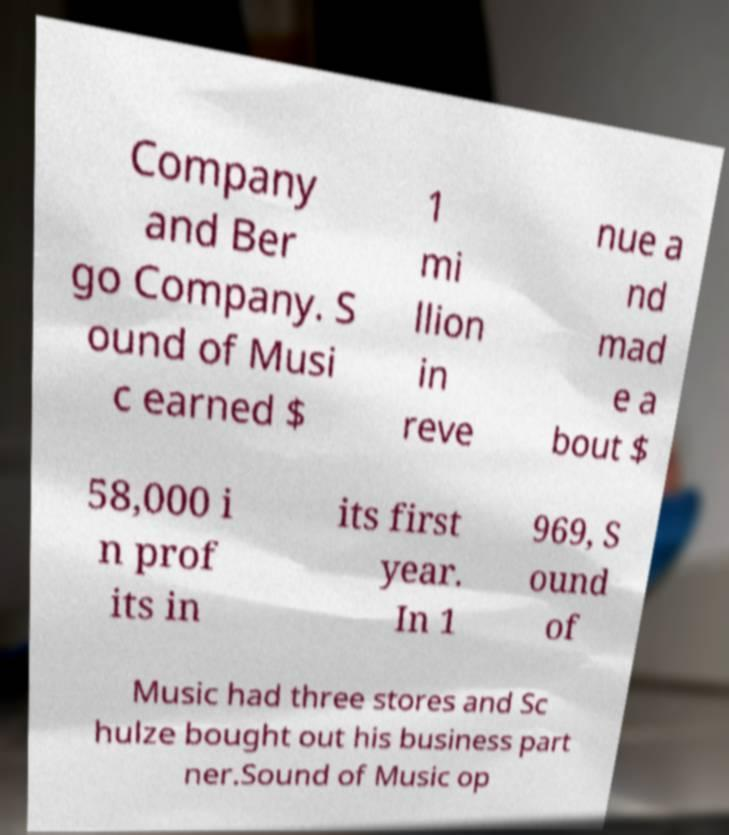Could you extract and type out the text from this image? Company and Ber go Company. S ound of Musi c earned $ 1 mi llion in reve nue a nd mad e a bout $ 58,000 i n prof its in its first year. In 1 969, S ound of Music had three stores and Sc hulze bought out his business part ner.Sound of Music op 